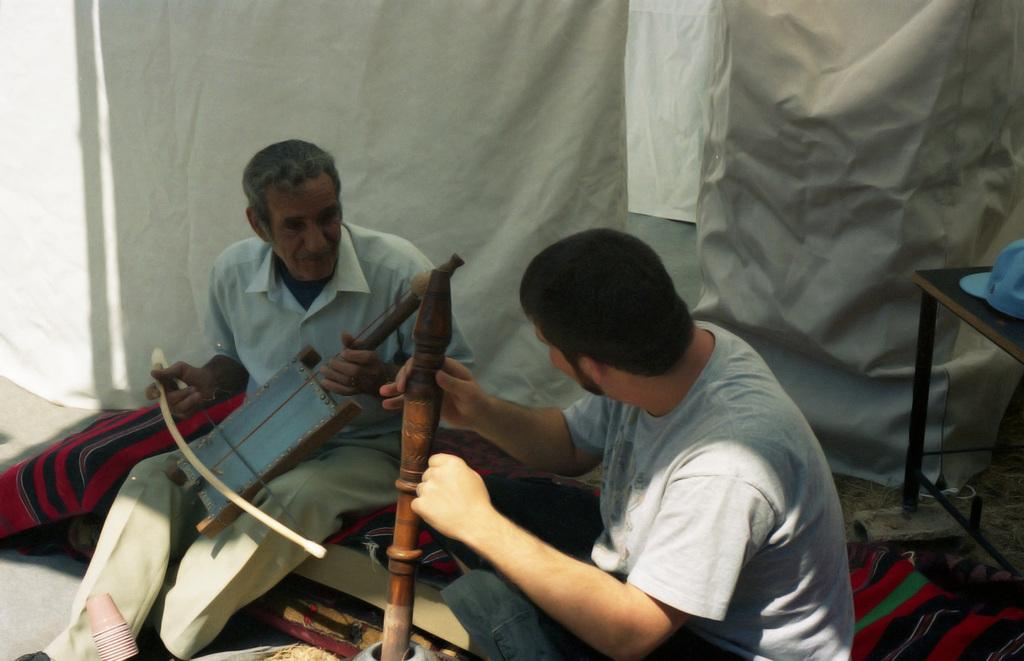How many people are present in the image? There are two people in the image. What are the people doing in the image? The two people are sitting. What are the people holding in their hands? The people are holding musical instruments in their hands. What color is the cloth in the background? There is a white color cloth in the background. Can you tell me how many thumbs are visible on the people's hands in the image? There is no information about the number of thumbs visible on the people's hands in the image. Is there a jail present in the image? There is no mention of a jail in the image. 